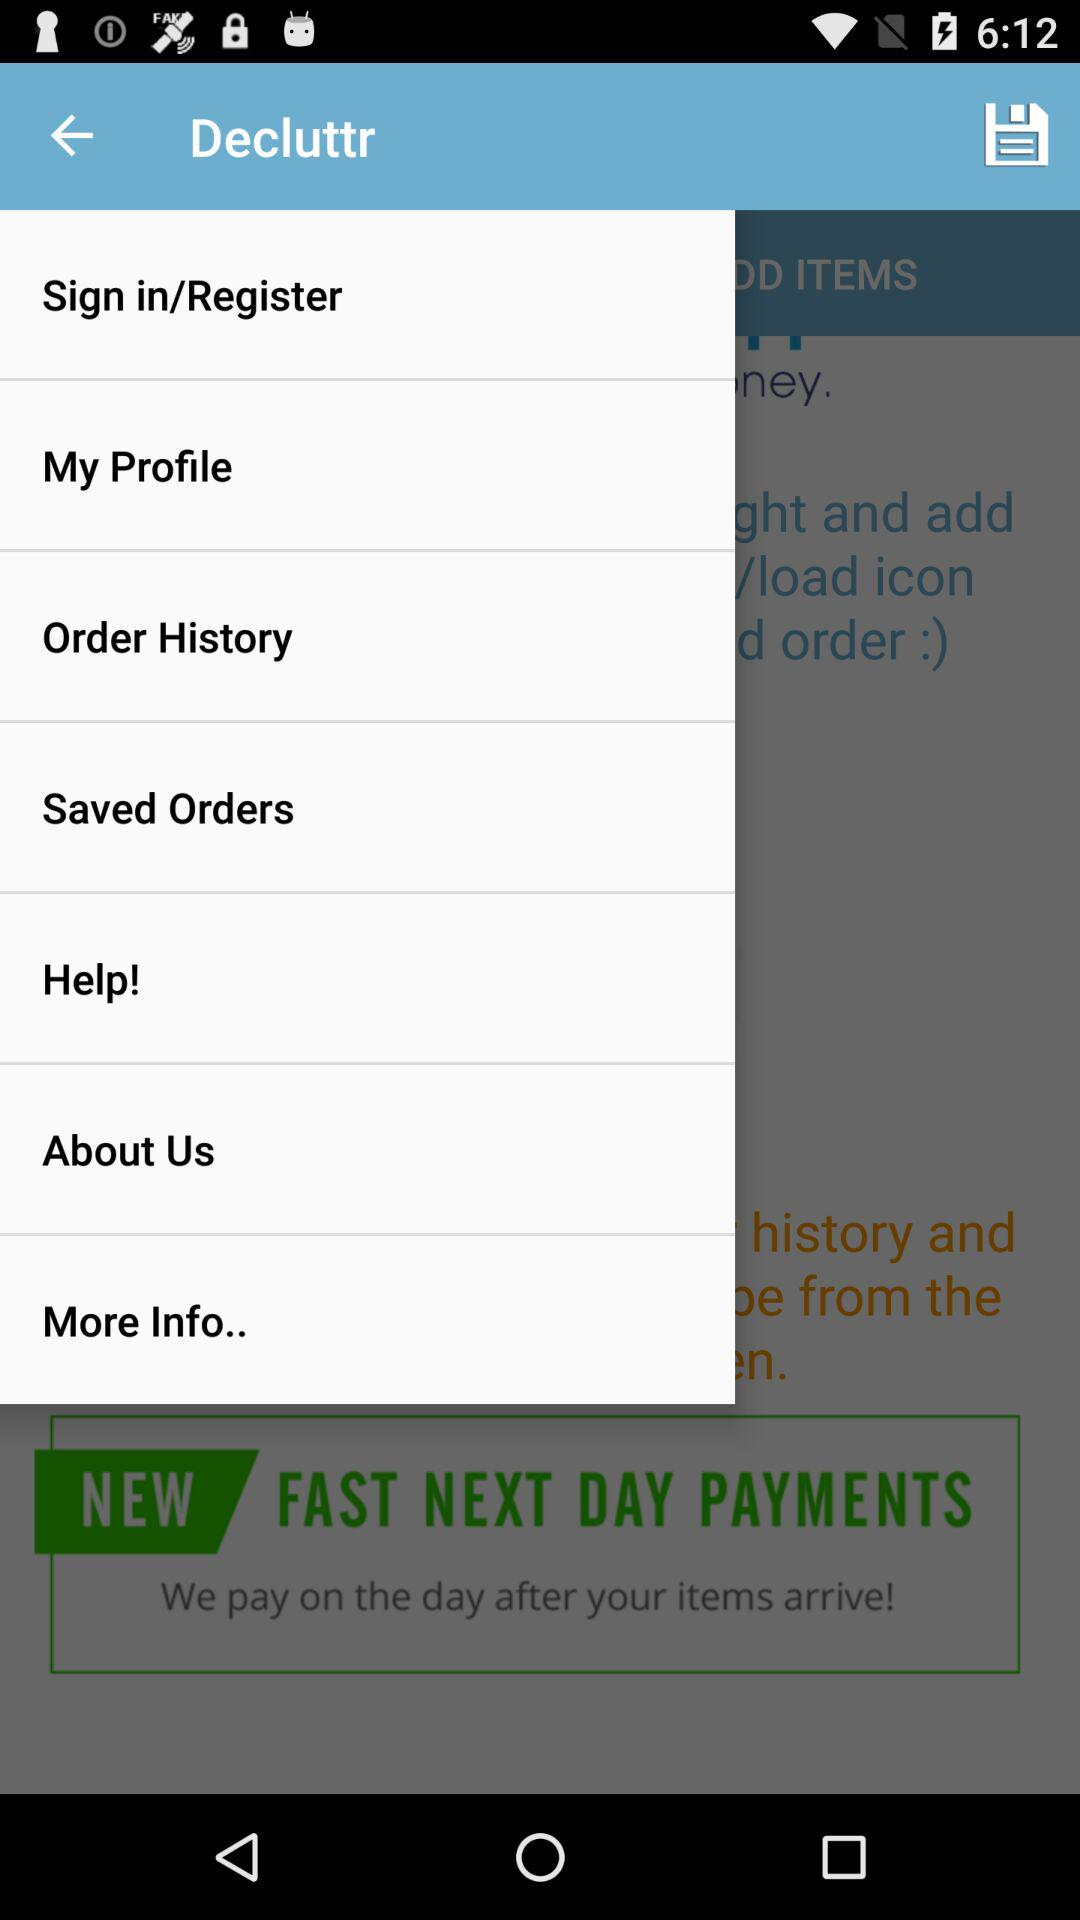What is the name of the application? The name of the application is "Decluttr". 